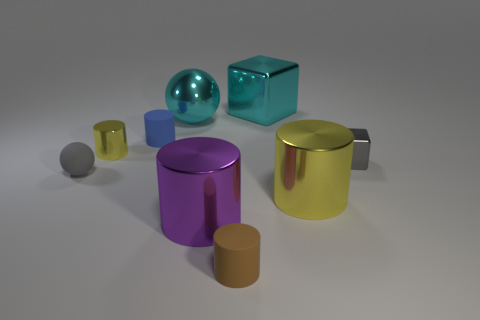Subtract 3 cylinders. How many cylinders are left? 2 Subtract all small metallic cylinders. How many cylinders are left? 4 Subtract all purple cylinders. How many cylinders are left? 4 Add 1 metal balls. How many objects exist? 10 Subtract all blue cylinders. Subtract all gray cubes. How many cylinders are left? 4 Subtract all balls. How many objects are left? 7 Subtract 0 brown cubes. How many objects are left? 9 Subtract all big brown things. Subtract all rubber spheres. How many objects are left? 8 Add 4 small brown rubber cylinders. How many small brown rubber cylinders are left? 5 Add 1 large brown cylinders. How many large brown cylinders exist? 1 